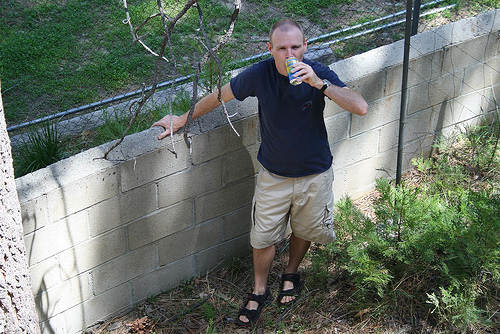<image>
Is the man on the juice cane? Yes. Looking at the image, I can see the man is positioned on top of the juice cane, with the juice cane providing support. Is the can next to the man? No. The can is not positioned next to the man. They are located in different areas of the scene. 